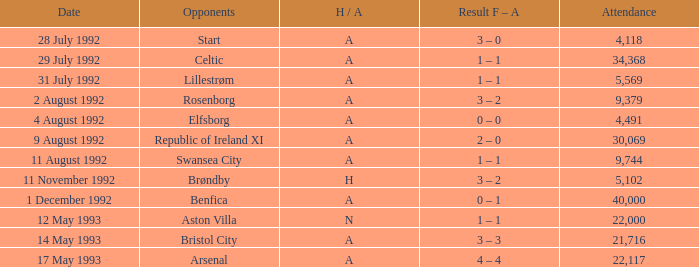What was the H/A on 29 july 1992? A. 